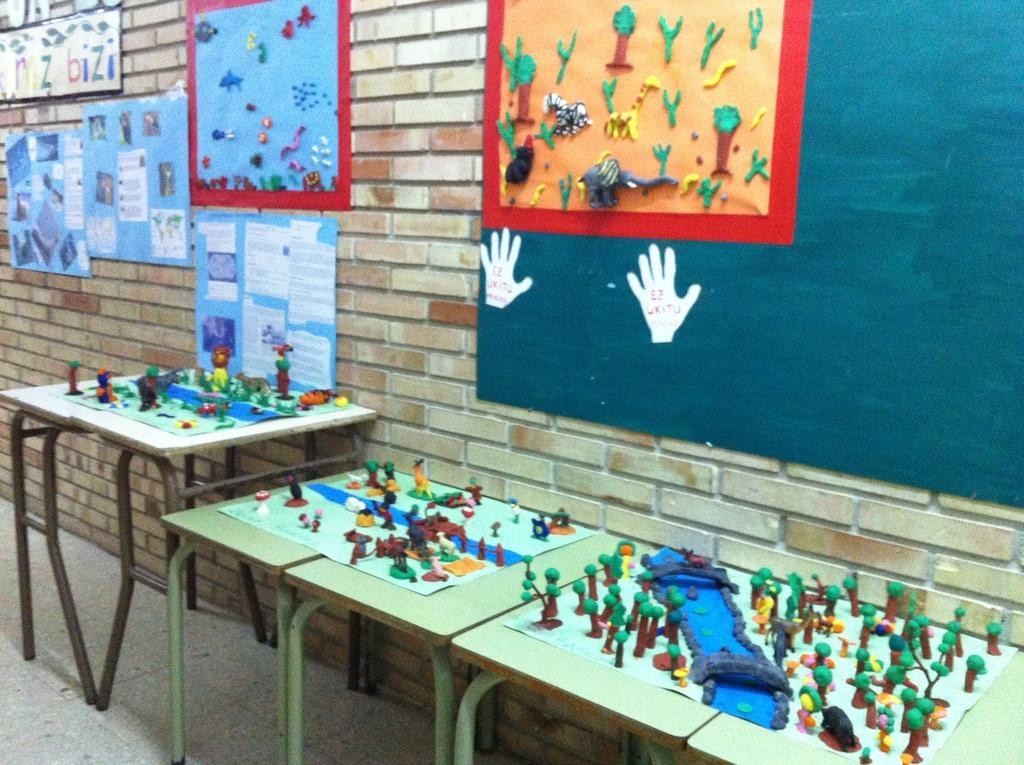What type of space is depicted in the image? There is a room in the image. What can be seen on the walls of the room? There are posters on the wall in the room. What type of furniture is present in the room? There are tables in the room. What items are placed on the tables? There are toys on the tables. What is the condition of the ladybug on the table in the image? There is no ladybug present in the image; the tables have toys on them. 